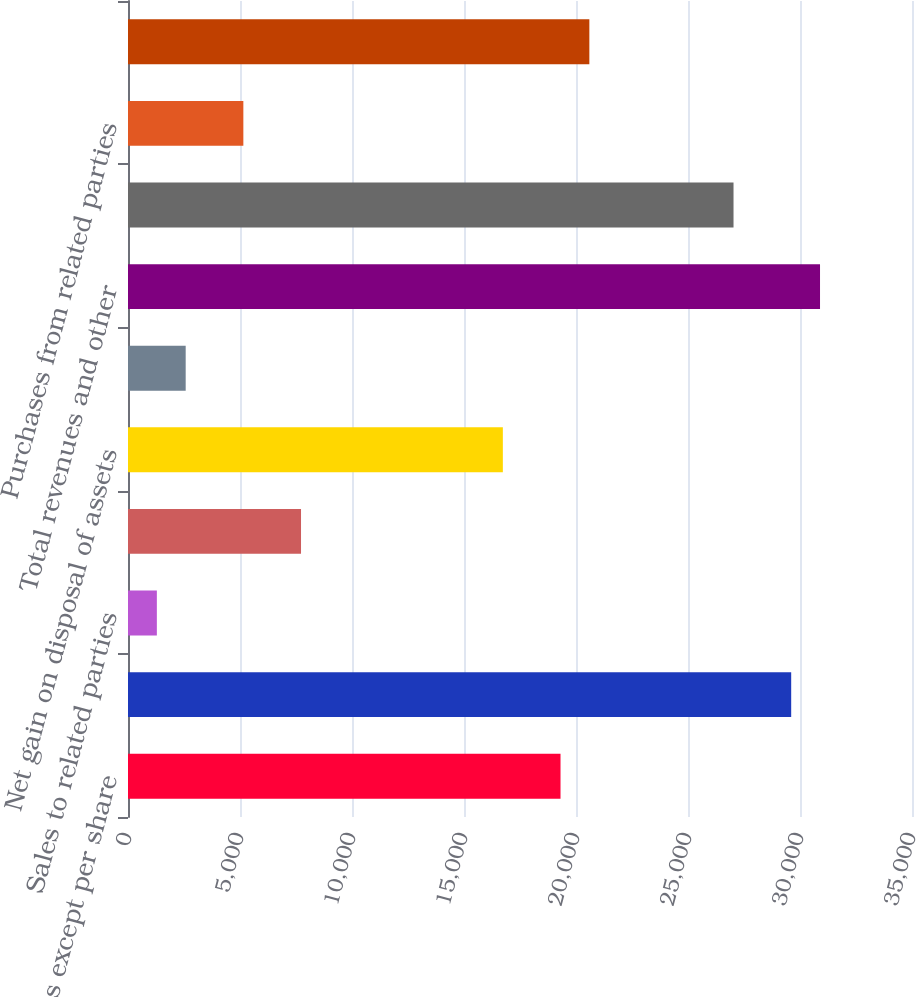Convert chart. <chart><loc_0><loc_0><loc_500><loc_500><bar_chart><fcel>(In millions except per share<fcel>Sales and other operating<fcel>Sales to related parties<fcel>Income from equity method<fcel>Net gain on disposal of assets<fcel>Other income<fcel>Total revenues and other<fcel>Cost of revenues (excludes<fcel>Purchases from related parties<fcel>Depreciation depletion and<nl><fcel>19309<fcel>29606.6<fcel>1288.19<fcel>7724.19<fcel>16734.6<fcel>2575.39<fcel>30893.8<fcel>27032.2<fcel>5149.79<fcel>20596.2<nl></chart> 